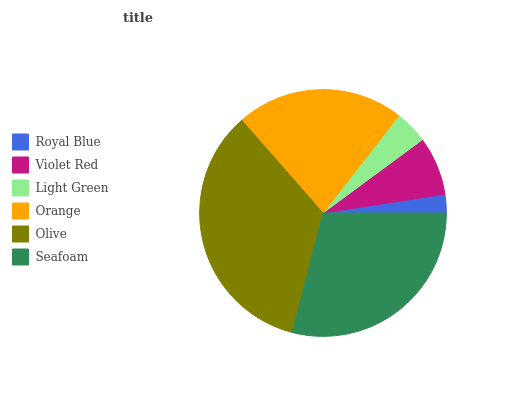Is Royal Blue the minimum?
Answer yes or no. Yes. Is Olive the maximum?
Answer yes or no. Yes. Is Violet Red the minimum?
Answer yes or no. No. Is Violet Red the maximum?
Answer yes or no. No. Is Violet Red greater than Royal Blue?
Answer yes or no. Yes. Is Royal Blue less than Violet Red?
Answer yes or no. Yes. Is Royal Blue greater than Violet Red?
Answer yes or no. No. Is Violet Red less than Royal Blue?
Answer yes or no. No. Is Orange the high median?
Answer yes or no. Yes. Is Violet Red the low median?
Answer yes or no. Yes. Is Royal Blue the high median?
Answer yes or no. No. Is Orange the low median?
Answer yes or no. No. 